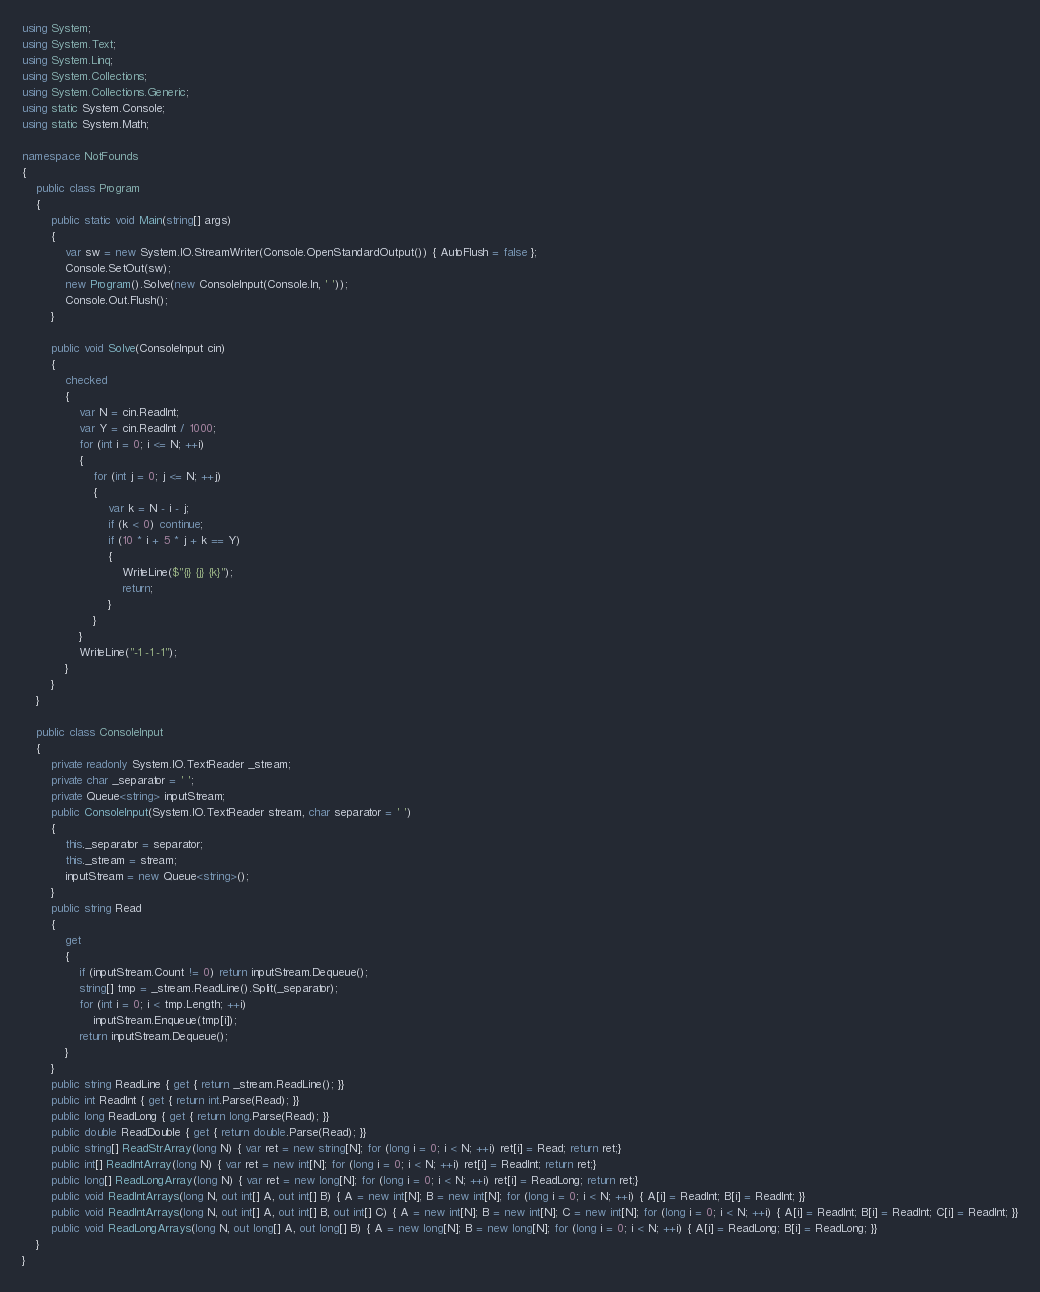Convert code to text. <code><loc_0><loc_0><loc_500><loc_500><_C#_>using System;
using System.Text;
using System.Linq;
using System.Collections;
using System.Collections.Generic;
using static System.Console;
using static System.Math;

namespace NotFounds
{
    public class Program
    {
        public static void Main(string[] args)
        {
            var sw = new System.IO.StreamWriter(Console.OpenStandardOutput()) { AutoFlush = false };
            Console.SetOut(sw);
            new Program().Solve(new ConsoleInput(Console.In, ' '));
            Console.Out.Flush();
        }

        public void Solve(ConsoleInput cin)
        {
            checked
            {
                var N = cin.ReadInt;
                var Y = cin.ReadInt / 1000;
                for (int i = 0; i <= N; ++i)
                {
                    for (int j = 0; j <= N; ++j)
                    {
                        var k = N - i - j;
                        if (k < 0) continue;
                        if (10 * i + 5 * j + k == Y)
                        {
                            WriteLine($"{i} {j} {k}");
                            return;
                        }
                    }
                }
                WriteLine("-1 -1 -1");
            }
        }
    }

    public class ConsoleInput
    {
        private readonly System.IO.TextReader _stream;
        private char _separator = ' ';
        private Queue<string> inputStream;
        public ConsoleInput(System.IO.TextReader stream, char separator = ' ')
        {
            this._separator = separator;
            this._stream = stream;
            inputStream = new Queue<string>();
        }
        public string Read
        {
            get
            {
                if (inputStream.Count != 0) return inputStream.Dequeue();
                string[] tmp = _stream.ReadLine().Split(_separator);
                for (int i = 0; i < tmp.Length; ++i)
                    inputStream.Enqueue(tmp[i]);
                return inputStream.Dequeue();
            }
        }
        public string ReadLine { get { return _stream.ReadLine(); }}
        public int ReadInt { get { return int.Parse(Read); }}
        public long ReadLong { get { return long.Parse(Read); }}
        public double ReadDouble { get { return double.Parse(Read); }}
        public string[] ReadStrArray(long N) { var ret = new string[N]; for (long i = 0; i < N; ++i) ret[i] = Read; return ret;}
        public int[] ReadIntArray(long N) { var ret = new int[N]; for (long i = 0; i < N; ++i) ret[i] = ReadInt; return ret;}
        public long[] ReadLongArray(long N) { var ret = new long[N]; for (long i = 0; i < N; ++i) ret[i] = ReadLong; return ret;}
        public void ReadIntArrays(long N, out int[] A, out int[] B) { A = new int[N]; B = new int[N]; for (long i = 0; i < N; ++i) { A[i] = ReadInt; B[i] = ReadInt; }}
        public void ReadIntArrays(long N, out int[] A, out int[] B, out int[] C) { A = new int[N]; B = new int[N]; C = new int[N]; for (long i = 0; i < N; ++i) { A[i] = ReadInt; B[i] = ReadInt; C[i] = ReadInt; }}
        public void ReadLongArrays(long N, out long[] A, out long[] B) { A = new long[N]; B = new long[N]; for (long i = 0; i < N; ++i) { A[i] = ReadLong; B[i] = ReadLong; }}
    }
}
</code> 